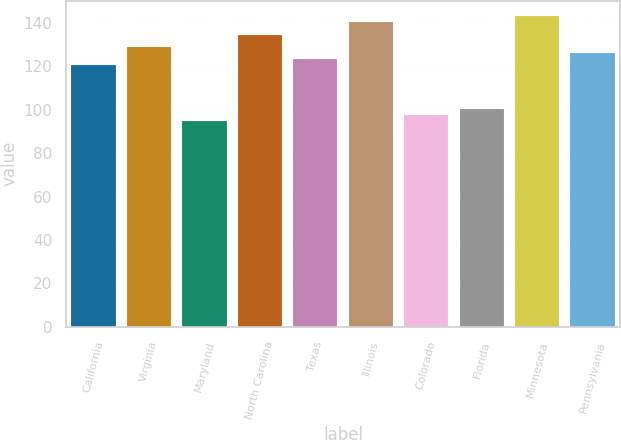<chart> <loc_0><loc_0><loc_500><loc_500><bar_chart><fcel>California<fcel>Virginia<fcel>Maryland<fcel>North Carolina<fcel>Texas<fcel>Illinois<fcel>Colorado<fcel>Florida<fcel>Minnesota<fcel>Pennsylvania<nl><fcel>120.44<fcel>128.96<fcel>94.88<fcel>134.64<fcel>123.28<fcel>140.32<fcel>97.72<fcel>100.56<fcel>143.16<fcel>126.12<nl></chart> 